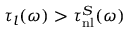<formula> <loc_0><loc_0><loc_500><loc_500>\tau _ { l } ( \omega ) > \tau _ { n l } ^ { S } ( \omega )</formula> 